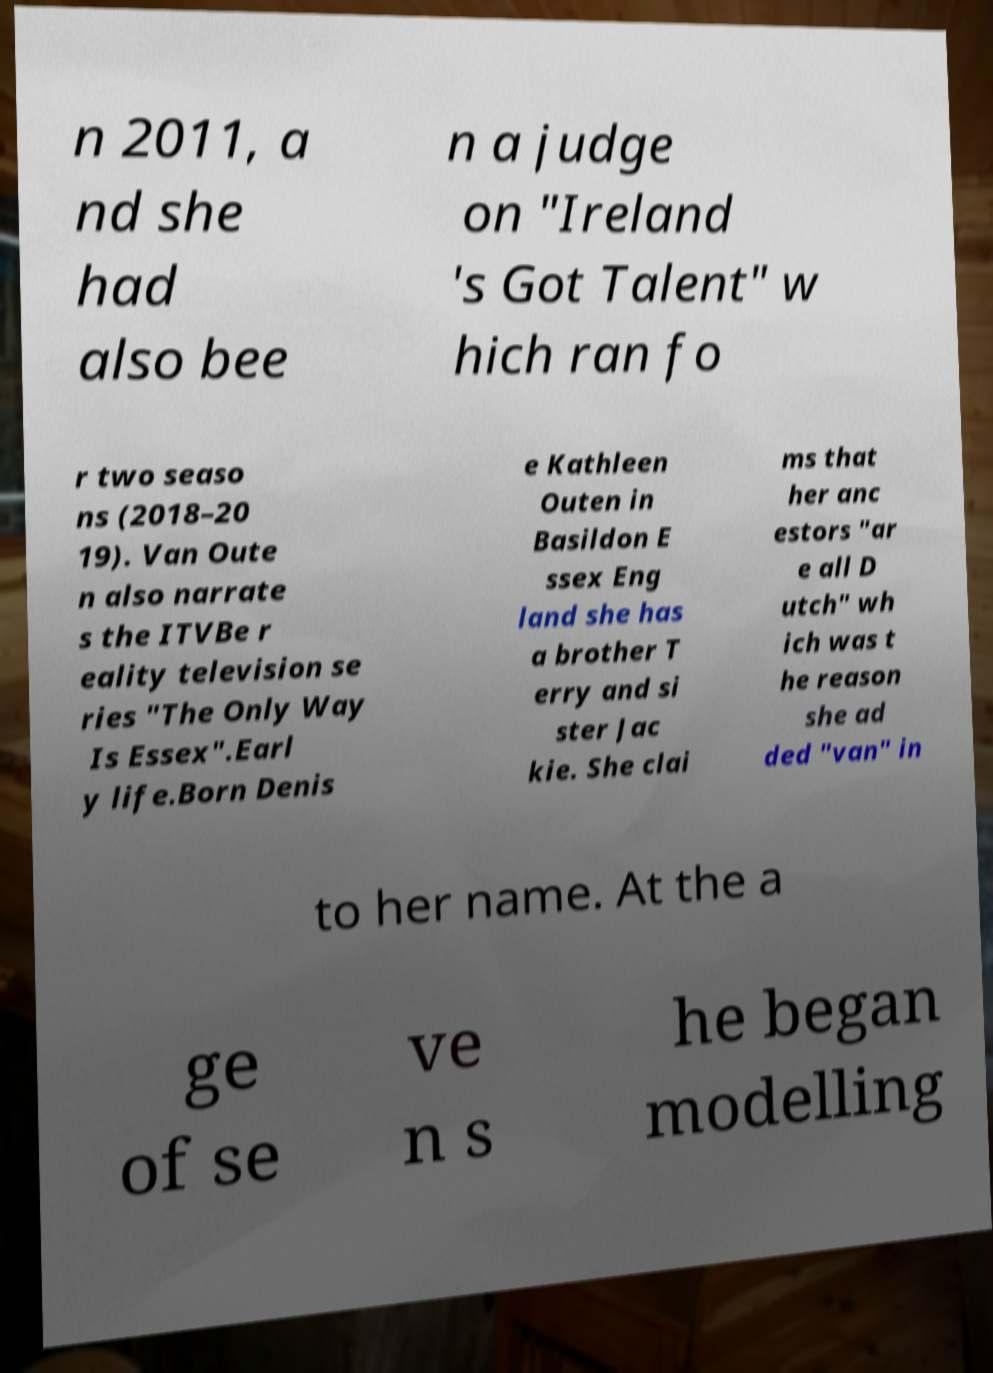Please read and relay the text visible in this image. What does it say? n 2011, a nd she had also bee n a judge on "Ireland 's Got Talent" w hich ran fo r two seaso ns (2018–20 19). Van Oute n also narrate s the ITVBe r eality television se ries "The Only Way Is Essex".Earl y life.Born Denis e Kathleen Outen in Basildon E ssex Eng land she has a brother T erry and si ster Jac kie. She clai ms that her anc estors "ar e all D utch" wh ich was t he reason she ad ded "van" in to her name. At the a ge of se ve n s he began modelling 